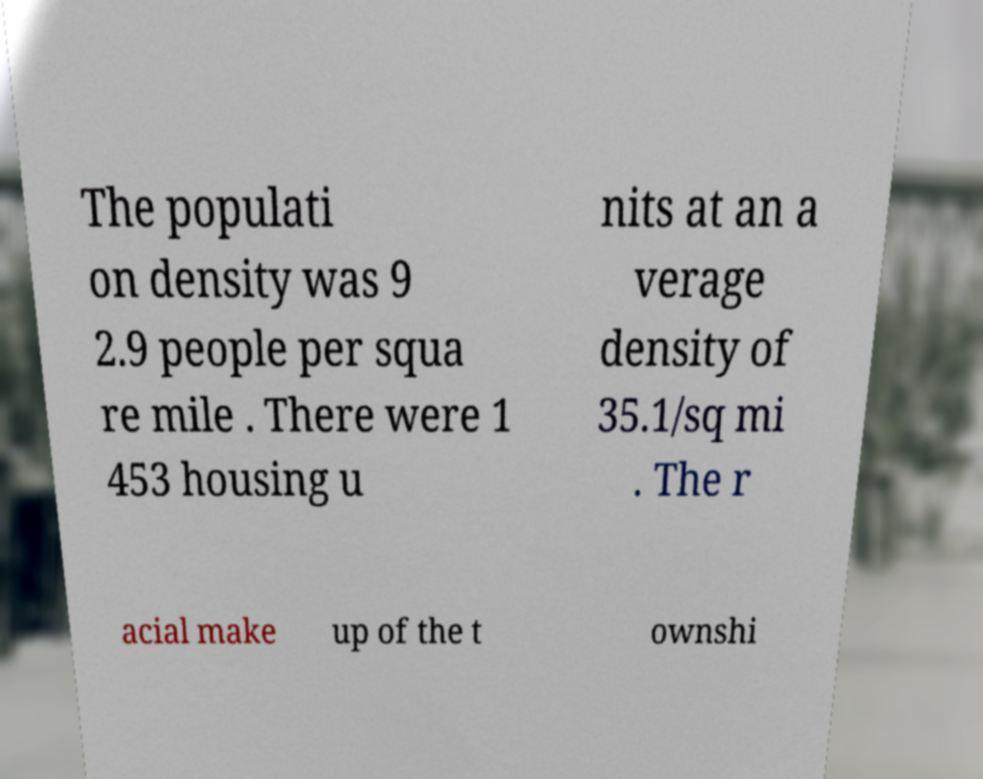Please read and relay the text visible in this image. What does it say? The populati on density was 9 2.9 people per squa re mile . There were 1 453 housing u nits at an a verage density of 35.1/sq mi . The r acial make up of the t ownshi 